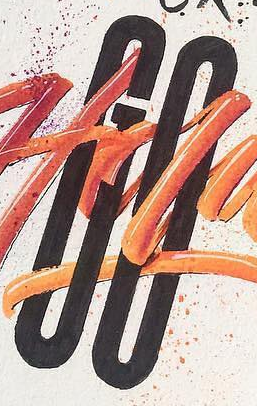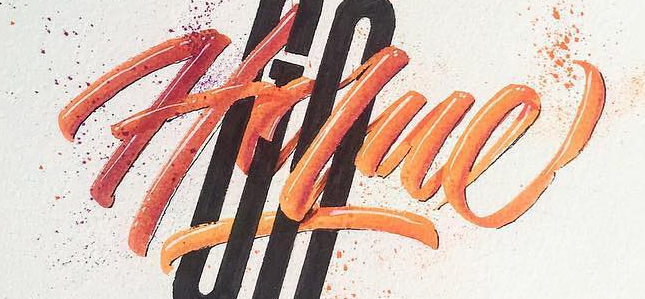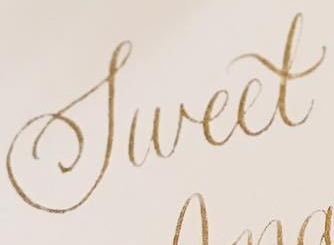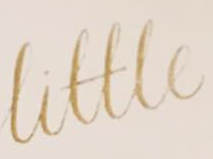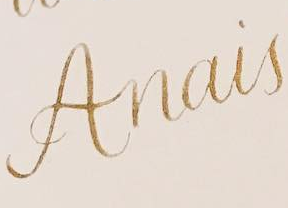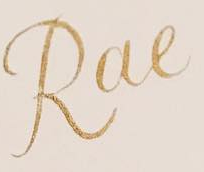What text appears in these images from left to right, separated by a semicolon? GO; Holue; Sweet; Little; Anais; Rae 